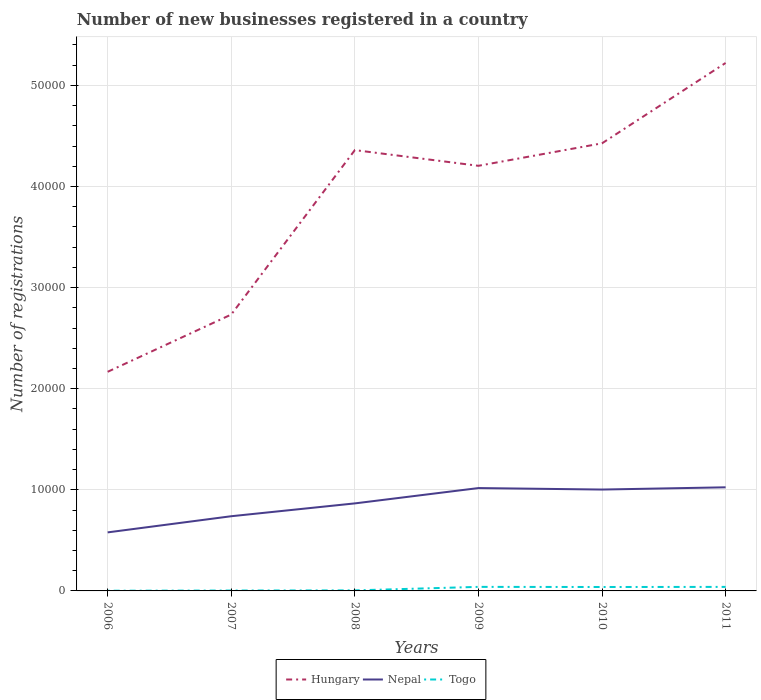How many different coloured lines are there?
Your answer should be very brief. 3. Is the number of lines equal to the number of legend labels?
Your answer should be compact. Yes. In which year was the number of new businesses registered in Nepal maximum?
Provide a short and direct response. 2006. What is the total number of new businesses registered in Togo in the graph?
Provide a short and direct response. -335. What is the difference between the highest and the second highest number of new businesses registered in Nepal?
Ensure brevity in your answer.  4458. What is the difference between the highest and the lowest number of new businesses registered in Hungary?
Offer a very short reply. 4. How many lines are there?
Your answer should be very brief. 3. How many years are there in the graph?
Your response must be concise. 6. Does the graph contain grids?
Give a very brief answer. Yes. How are the legend labels stacked?
Give a very brief answer. Horizontal. What is the title of the graph?
Give a very brief answer. Number of new businesses registered in a country. What is the label or title of the X-axis?
Offer a terse response. Years. What is the label or title of the Y-axis?
Your answer should be compact. Number of registrations. What is the Number of registrations of Hungary in 2006?
Provide a succinct answer. 2.17e+04. What is the Number of registrations of Nepal in 2006?
Offer a very short reply. 5789. What is the Number of registrations of Hungary in 2007?
Keep it short and to the point. 2.73e+04. What is the Number of registrations of Nepal in 2007?
Your response must be concise. 7388. What is the Number of registrations of Hungary in 2008?
Offer a terse response. 4.36e+04. What is the Number of registrations of Nepal in 2008?
Offer a very short reply. 8657. What is the Number of registrations of Hungary in 2009?
Make the answer very short. 4.20e+04. What is the Number of registrations of Nepal in 2009?
Make the answer very short. 1.02e+04. What is the Number of registrations of Togo in 2009?
Provide a succinct answer. 400. What is the Number of registrations in Hungary in 2010?
Offer a terse response. 4.43e+04. What is the Number of registrations in Nepal in 2010?
Your answer should be compact. 1.00e+04. What is the Number of registrations in Togo in 2010?
Give a very brief answer. 388. What is the Number of registrations of Hungary in 2011?
Keep it short and to the point. 5.22e+04. What is the Number of registrations in Nepal in 2011?
Make the answer very short. 1.02e+04. What is the Number of registrations in Togo in 2011?
Your answer should be compact. 398. Across all years, what is the maximum Number of registrations of Hungary?
Your response must be concise. 5.22e+04. Across all years, what is the maximum Number of registrations of Nepal?
Give a very brief answer. 1.02e+04. Across all years, what is the maximum Number of registrations of Togo?
Ensure brevity in your answer.  400. Across all years, what is the minimum Number of registrations in Hungary?
Give a very brief answer. 2.17e+04. Across all years, what is the minimum Number of registrations of Nepal?
Provide a short and direct response. 5789. Across all years, what is the minimum Number of registrations of Togo?
Provide a succinct answer. 19. What is the total Number of registrations in Hungary in the graph?
Your answer should be very brief. 2.31e+05. What is the total Number of registrations of Nepal in the graph?
Provide a succinct answer. 5.23e+04. What is the total Number of registrations in Togo in the graph?
Offer a terse response. 1297. What is the difference between the Number of registrations of Hungary in 2006 and that in 2007?
Offer a very short reply. -5663. What is the difference between the Number of registrations in Nepal in 2006 and that in 2007?
Keep it short and to the point. -1599. What is the difference between the Number of registrations of Hungary in 2006 and that in 2008?
Make the answer very short. -2.19e+04. What is the difference between the Number of registrations in Nepal in 2006 and that in 2008?
Provide a short and direct response. -2868. What is the difference between the Number of registrations of Togo in 2006 and that in 2008?
Your answer should be compact. -34. What is the difference between the Number of registrations in Hungary in 2006 and that in 2009?
Your answer should be very brief. -2.04e+04. What is the difference between the Number of registrations of Nepal in 2006 and that in 2009?
Keep it short and to the point. -4384. What is the difference between the Number of registrations of Togo in 2006 and that in 2009?
Give a very brief answer. -381. What is the difference between the Number of registrations in Hungary in 2006 and that in 2010?
Your answer should be compact. -2.26e+04. What is the difference between the Number of registrations in Nepal in 2006 and that in 2010?
Provide a short and direct response. -4238. What is the difference between the Number of registrations of Togo in 2006 and that in 2010?
Offer a terse response. -369. What is the difference between the Number of registrations in Hungary in 2006 and that in 2011?
Ensure brevity in your answer.  -3.05e+04. What is the difference between the Number of registrations in Nepal in 2006 and that in 2011?
Provide a short and direct response. -4458. What is the difference between the Number of registrations in Togo in 2006 and that in 2011?
Provide a succinct answer. -379. What is the difference between the Number of registrations in Hungary in 2007 and that in 2008?
Offer a terse response. -1.63e+04. What is the difference between the Number of registrations in Nepal in 2007 and that in 2008?
Provide a succinct answer. -1269. What is the difference between the Number of registrations in Togo in 2007 and that in 2008?
Provide a succinct answer. -14. What is the difference between the Number of registrations of Hungary in 2007 and that in 2009?
Give a very brief answer. -1.47e+04. What is the difference between the Number of registrations in Nepal in 2007 and that in 2009?
Offer a terse response. -2785. What is the difference between the Number of registrations in Togo in 2007 and that in 2009?
Give a very brief answer. -361. What is the difference between the Number of registrations of Hungary in 2007 and that in 2010?
Offer a terse response. -1.69e+04. What is the difference between the Number of registrations in Nepal in 2007 and that in 2010?
Your answer should be compact. -2639. What is the difference between the Number of registrations of Togo in 2007 and that in 2010?
Make the answer very short. -349. What is the difference between the Number of registrations of Hungary in 2007 and that in 2011?
Make the answer very short. -2.49e+04. What is the difference between the Number of registrations in Nepal in 2007 and that in 2011?
Provide a succinct answer. -2859. What is the difference between the Number of registrations in Togo in 2007 and that in 2011?
Your answer should be compact. -359. What is the difference between the Number of registrations in Hungary in 2008 and that in 2009?
Provide a short and direct response. 1552. What is the difference between the Number of registrations of Nepal in 2008 and that in 2009?
Your answer should be compact. -1516. What is the difference between the Number of registrations in Togo in 2008 and that in 2009?
Ensure brevity in your answer.  -347. What is the difference between the Number of registrations in Hungary in 2008 and that in 2010?
Provide a succinct answer. -671. What is the difference between the Number of registrations in Nepal in 2008 and that in 2010?
Give a very brief answer. -1370. What is the difference between the Number of registrations in Togo in 2008 and that in 2010?
Make the answer very short. -335. What is the difference between the Number of registrations in Hungary in 2008 and that in 2011?
Your answer should be compact. -8619. What is the difference between the Number of registrations of Nepal in 2008 and that in 2011?
Provide a short and direct response. -1590. What is the difference between the Number of registrations in Togo in 2008 and that in 2011?
Your answer should be compact. -345. What is the difference between the Number of registrations in Hungary in 2009 and that in 2010?
Make the answer very short. -2223. What is the difference between the Number of registrations in Nepal in 2009 and that in 2010?
Your answer should be very brief. 146. What is the difference between the Number of registrations of Hungary in 2009 and that in 2011?
Your answer should be compact. -1.02e+04. What is the difference between the Number of registrations of Nepal in 2009 and that in 2011?
Offer a terse response. -74. What is the difference between the Number of registrations in Hungary in 2010 and that in 2011?
Provide a short and direct response. -7948. What is the difference between the Number of registrations in Nepal in 2010 and that in 2011?
Your answer should be compact. -220. What is the difference between the Number of registrations in Hungary in 2006 and the Number of registrations in Nepal in 2007?
Your answer should be very brief. 1.43e+04. What is the difference between the Number of registrations in Hungary in 2006 and the Number of registrations in Togo in 2007?
Your response must be concise. 2.16e+04. What is the difference between the Number of registrations in Nepal in 2006 and the Number of registrations in Togo in 2007?
Your response must be concise. 5750. What is the difference between the Number of registrations in Hungary in 2006 and the Number of registrations in Nepal in 2008?
Your answer should be compact. 1.30e+04. What is the difference between the Number of registrations in Hungary in 2006 and the Number of registrations in Togo in 2008?
Make the answer very short. 2.16e+04. What is the difference between the Number of registrations of Nepal in 2006 and the Number of registrations of Togo in 2008?
Make the answer very short. 5736. What is the difference between the Number of registrations of Hungary in 2006 and the Number of registrations of Nepal in 2009?
Keep it short and to the point. 1.15e+04. What is the difference between the Number of registrations in Hungary in 2006 and the Number of registrations in Togo in 2009?
Keep it short and to the point. 2.13e+04. What is the difference between the Number of registrations of Nepal in 2006 and the Number of registrations of Togo in 2009?
Make the answer very short. 5389. What is the difference between the Number of registrations of Hungary in 2006 and the Number of registrations of Nepal in 2010?
Ensure brevity in your answer.  1.16e+04. What is the difference between the Number of registrations in Hungary in 2006 and the Number of registrations in Togo in 2010?
Make the answer very short. 2.13e+04. What is the difference between the Number of registrations of Nepal in 2006 and the Number of registrations of Togo in 2010?
Your answer should be compact. 5401. What is the difference between the Number of registrations in Hungary in 2006 and the Number of registrations in Nepal in 2011?
Provide a succinct answer. 1.14e+04. What is the difference between the Number of registrations of Hungary in 2006 and the Number of registrations of Togo in 2011?
Ensure brevity in your answer.  2.13e+04. What is the difference between the Number of registrations in Nepal in 2006 and the Number of registrations in Togo in 2011?
Provide a short and direct response. 5391. What is the difference between the Number of registrations of Hungary in 2007 and the Number of registrations of Nepal in 2008?
Make the answer very short. 1.87e+04. What is the difference between the Number of registrations of Hungary in 2007 and the Number of registrations of Togo in 2008?
Provide a succinct answer. 2.73e+04. What is the difference between the Number of registrations of Nepal in 2007 and the Number of registrations of Togo in 2008?
Ensure brevity in your answer.  7335. What is the difference between the Number of registrations of Hungary in 2007 and the Number of registrations of Nepal in 2009?
Make the answer very short. 1.72e+04. What is the difference between the Number of registrations in Hungary in 2007 and the Number of registrations in Togo in 2009?
Provide a short and direct response. 2.69e+04. What is the difference between the Number of registrations of Nepal in 2007 and the Number of registrations of Togo in 2009?
Keep it short and to the point. 6988. What is the difference between the Number of registrations in Hungary in 2007 and the Number of registrations in Nepal in 2010?
Provide a succinct answer. 1.73e+04. What is the difference between the Number of registrations of Hungary in 2007 and the Number of registrations of Togo in 2010?
Make the answer very short. 2.69e+04. What is the difference between the Number of registrations of Nepal in 2007 and the Number of registrations of Togo in 2010?
Make the answer very short. 7000. What is the difference between the Number of registrations in Hungary in 2007 and the Number of registrations in Nepal in 2011?
Ensure brevity in your answer.  1.71e+04. What is the difference between the Number of registrations in Hungary in 2007 and the Number of registrations in Togo in 2011?
Your answer should be very brief. 2.69e+04. What is the difference between the Number of registrations in Nepal in 2007 and the Number of registrations in Togo in 2011?
Provide a short and direct response. 6990. What is the difference between the Number of registrations in Hungary in 2008 and the Number of registrations in Nepal in 2009?
Your answer should be compact. 3.34e+04. What is the difference between the Number of registrations in Hungary in 2008 and the Number of registrations in Togo in 2009?
Make the answer very short. 4.32e+04. What is the difference between the Number of registrations in Nepal in 2008 and the Number of registrations in Togo in 2009?
Keep it short and to the point. 8257. What is the difference between the Number of registrations of Hungary in 2008 and the Number of registrations of Nepal in 2010?
Your answer should be compact. 3.36e+04. What is the difference between the Number of registrations in Hungary in 2008 and the Number of registrations in Togo in 2010?
Ensure brevity in your answer.  4.32e+04. What is the difference between the Number of registrations in Nepal in 2008 and the Number of registrations in Togo in 2010?
Your response must be concise. 8269. What is the difference between the Number of registrations of Hungary in 2008 and the Number of registrations of Nepal in 2011?
Give a very brief answer. 3.34e+04. What is the difference between the Number of registrations of Hungary in 2008 and the Number of registrations of Togo in 2011?
Provide a succinct answer. 4.32e+04. What is the difference between the Number of registrations of Nepal in 2008 and the Number of registrations of Togo in 2011?
Make the answer very short. 8259. What is the difference between the Number of registrations in Hungary in 2009 and the Number of registrations in Nepal in 2010?
Provide a short and direct response. 3.20e+04. What is the difference between the Number of registrations of Hungary in 2009 and the Number of registrations of Togo in 2010?
Offer a terse response. 4.17e+04. What is the difference between the Number of registrations in Nepal in 2009 and the Number of registrations in Togo in 2010?
Give a very brief answer. 9785. What is the difference between the Number of registrations in Hungary in 2009 and the Number of registrations in Nepal in 2011?
Your answer should be compact. 3.18e+04. What is the difference between the Number of registrations in Hungary in 2009 and the Number of registrations in Togo in 2011?
Your response must be concise. 4.16e+04. What is the difference between the Number of registrations in Nepal in 2009 and the Number of registrations in Togo in 2011?
Ensure brevity in your answer.  9775. What is the difference between the Number of registrations of Hungary in 2010 and the Number of registrations of Nepal in 2011?
Provide a short and direct response. 3.40e+04. What is the difference between the Number of registrations in Hungary in 2010 and the Number of registrations in Togo in 2011?
Your answer should be very brief. 4.39e+04. What is the difference between the Number of registrations of Nepal in 2010 and the Number of registrations of Togo in 2011?
Ensure brevity in your answer.  9629. What is the average Number of registrations in Hungary per year?
Keep it short and to the point. 3.85e+04. What is the average Number of registrations in Nepal per year?
Your answer should be compact. 8713.5. What is the average Number of registrations of Togo per year?
Make the answer very short. 216.17. In the year 2006, what is the difference between the Number of registrations of Hungary and Number of registrations of Nepal?
Give a very brief answer. 1.59e+04. In the year 2006, what is the difference between the Number of registrations in Hungary and Number of registrations in Togo?
Your answer should be very brief. 2.17e+04. In the year 2006, what is the difference between the Number of registrations of Nepal and Number of registrations of Togo?
Offer a terse response. 5770. In the year 2007, what is the difference between the Number of registrations in Hungary and Number of registrations in Nepal?
Provide a short and direct response. 1.99e+04. In the year 2007, what is the difference between the Number of registrations of Hungary and Number of registrations of Togo?
Provide a succinct answer. 2.73e+04. In the year 2007, what is the difference between the Number of registrations of Nepal and Number of registrations of Togo?
Provide a succinct answer. 7349. In the year 2008, what is the difference between the Number of registrations in Hungary and Number of registrations in Nepal?
Keep it short and to the point. 3.49e+04. In the year 2008, what is the difference between the Number of registrations of Hungary and Number of registrations of Togo?
Your answer should be compact. 4.35e+04. In the year 2008, what is the difference between the Number of registrations in Nepal and Number of registrations in Togo?
Your answer should be compact. 8604. In the year 2009, what is the difference between the Number of registrations of Hungary and Number of registrations of Nepal?
Your response must be concise. 3.19e+04. In the year 2009, what is the difference between the Number of registrations in Hungary and Number of registrations in Togo?
Your answer should be compact. 4.16e+04. In the year 2009, what is the difference between the Number of registrations in Nepal and Number of registrations in Togo?
Offer a very short reply. 9773. In the year 2010, what is the difference between the Number of registrations of Hungary and Number of registrations of Nepal?
Give a very brief answer. 3.42e+04. In the year 2010, what is the difference between the Number of registrations in Hungary and Number of registrations in Togo?
Offer a terse response. 4.39e+04. In the year 2010, what is the difference between the Number of registrations of Nepal and Number of registrations of Togo?
Your response must be concise. 9639. In the year 2011, what is the difference between the Number of registrations in Hungary and Number of registrations in Nepal?
Offer a terse response. 4.20e+04. In the year 2011, what is the difference between the Number of registrations in Hungary and Number of registrations in Togo?
Ensure brevity in your answer.  5.18e+04. In the year 2011, what is the difference between the Number of registrations of Nepal and Number of registrations of Togo?
Provide a short and direct response. 9849. What is the ratio of the Number of registrations in Hungary in 2006 to that in 2007?
Your answer should be very brief. 0.79. What is the ratio of the Number of registrations of Nepal in 2006 to that in 2007?
Offer a very short reply. 0.78. What is the ratio of the Number of registrations in Togo in 2006 to that in 2007?
Provide a succinct answer. 0.49. What is the ratio of the Number of registrations in Hungary in 2006 to that in 2008?
Your answer should be compact. 0.5. What is the ratio of the Number of registrations in Nepal in 2006 to that in 2008?
Provide a short and direct response. 0.67. What is the ratio of the Number of registrations in Togo in 2006 to that in 2008?
Your answer should be very brief. 0.36. What is the ratio of the Number of registrations in Hungary in 2006 to that in 2009?
Give a very brief answer. 0.52. What is the ratio of the Number of registrations of Nepal in 2006 to that in 2009?
Ensure brevity in your answer.  0.57. What is the ratio of the Number of registrations of Togo in 2006 to that in 2009?
Provide a short and direct response. 0.05. What is the ratio of the Number of registrations in Hungary in 2006 to that in 2010?
Your response must be concise. 0.49. What is the ratio of the Number of registrations of Nepal in 2006 to that in 2010?
Make the answer very short. 0.58. What is the ratio of the Number of registrations of Togo in 2006 to that in 2010?
Offer a terse response. 0.05. What is the ratio of the Number of registrations in Hungary in 2006 to that in 2011?
Offer a very short reply. 0.41. What is the ratio of the Number of registrations in Nepal in 2006 to that in 2011?
Give a very brief answer. 0.56. What is the ratio of the Number of registrations of Togo in 2006 to that in 2011?
Offer a terse response. 0.05. What is the ratio of the Number of registrations in Hungary in 2007 to that in 2008?
Your answer should be very brief. 0.63. What is the ratio of the Number of registrations in Nepal in 2007 to that in 2008?
Your answer should be compact. 0.85. What is the ratio of the Number of registrations in Togo in 2007 to that in 2008?
Ensure brevity in your answer.  0.74. What is the ratio of the Number of registrations in Hungary in 2007 to that in 2009?
Offer a terse response. 0.65. What is the ratio of the Number of registrations in Nepal in 2007 to that in 2009?
Offer a terse response. 0.73. What is the ratio of the Number of registrations of Togo in 2007 to that in 2009?
Keep it short and to the point. 0.1. What is the ratio of the Number of registrations in Hungary in 2007 to that in 2010?
Your response must be concise. 0.62. What is the ratio of the Number of registrations of Nepal in 2007 to that in 2010?
Your answer should be very brief. 0.74. What is the ratio of the Number of registrations of Togo in 2007 to that in 2010?
Your answer should be compact. 0.1. What is the ratio of the Number of registrations in Hungary in 2007 to that in 2011?
Offer a very short reply. 0.52. What is the ratio of the Number of registrations of Nepal in 2007 to that in 2011?
Keep it short and to the point. 0.72. What is the ratio of the Number of registrations of Togo in 2007 to that in 2011?
Ensure brevity in your answer.  0.1. What is the ratio of the Number of registrations of Hungary in 2008 to that in 2009?
Make the answer very short. 1.04. What is the ratio of the Number of registrations of Nepal in 2008 to that in 2009?
Make the answer very short. 0.85. What is the ratio of the Number of registrations of Togo in 2008 to that in 2009?
Offer a terse response. 0.13. What is the ratio of the Number of registrations in Nepal in 2008 to that in 2010?
Give a very brief answer. 0.86. What is the ratio of the Number of registrations of Togo in 2008 to that in 2010?
Give a very brief answer. 0.14. What is the ratio of the Number of registrations of Hungary in 2008 to that in 2011?
Your answer should be compact. 0.83. What is the ratio of the Number of registrations in Nepal in 2008 to that in 2011?
Ensure brevity in your answer.  0.84. What is the ratio of the Number of registrations of Togo in 2008 to that in 2011?
Keep it short and to the point. 0.13. What is the ratio of the Number of registrations in Hungary in 2009 to that in 2010?
Give a very brief answer. 0.95. What is the ratio of the Number of registrations of Nepal in 2009 to that in 2010?
Offer a very short reply. 1.01. What is the ratio of the Number of registrations of Togo in 2009 to that in 2010?
Ensure brevity in your answer.  1.03. What is the ratio of the Number of registrations of Hungary in 2009 to that in 2011?
Your answer should be compact. 0.81. What is the ratio of the Number of registrations in Togo in 2009 to that in 2011?
Keep it short and to the point. 1. What is the ratio of the Number of registrations in Hungary in 2010 to that in 2011?
Give a very brief answer. 0.85. What is the ratio of the Number of registrations in Nepal in 2010 to that in 2011?
Ensure brevity in your answer.  0.98. What is the ratio of the Number of registrations in Togo in 2010 to that in 2011?
Provide a succinct answer. 0.97. What is the difference between the highest and the second highest Number of registrations of Hungary?
Provide a succinct answer. 7948. What is the difference between the highest and the lowest Number of registrations in Hungary?
Offer a terse response. 3.05e+04. What is the difference between the highest and the lowest Number of registrations in Nepal?
Your response must be concise. 4458. What is the difference between the highest and the lowest Number of registrations in Togo?
Your answer should be very brief. 381. 